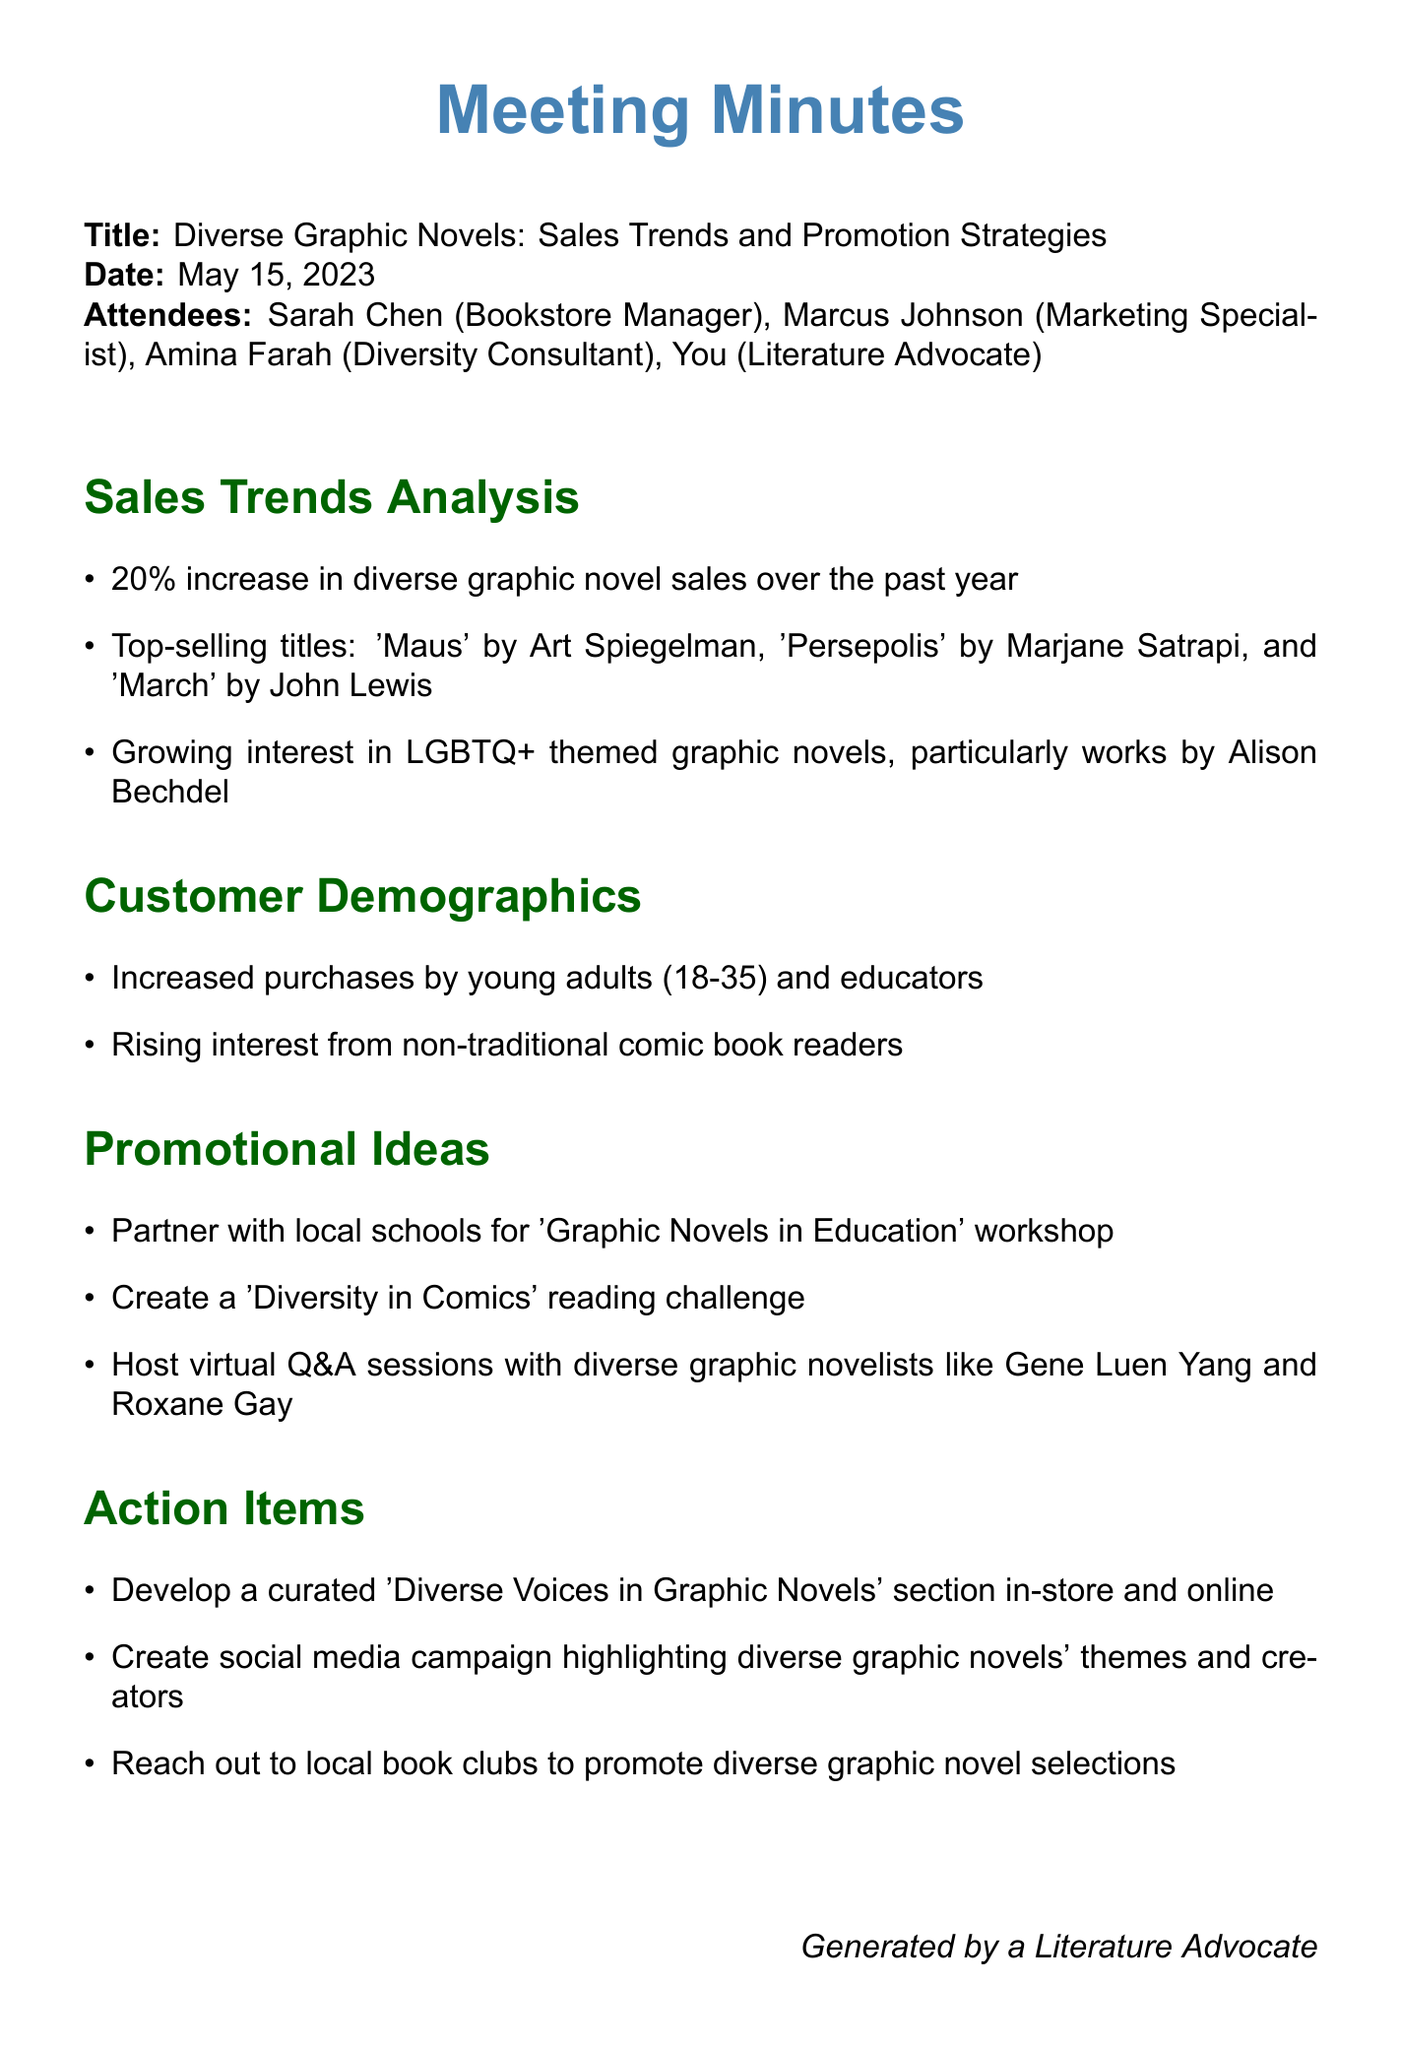What is the date of the meeting? The date of the meeting is explicitly stated in the document.
Answer: May 15, 2023 Who are the top-selling graphic novelists mentioned? The document lists specific titles and their authors that are top-selling graphic novels.
Answer: Art Spiegelman, Marjane Satrapi, John Lewis What is the percentage increase in diverse graphic novel sales? The document provides a specific statistic regarding the sales trend.
Answer: 20% Which demographic showed increased purchases? The document mentions specific customer demographics showing a rise in purchases.
Answer: Young adults (18-35) and educators What is one promotional idea mentioned in the meeting? The document lists several promotional strategies discussed during the meeting.
Answer: Graphic Novels in Education workshop What is the purpose of the 'Diversity in Comics' challenge? The document includes an agenda item that explains a new initiative for engagement.
Answer: To encourage diverse reading What action item involves social media? The document details specific actions to be taken based on the meeting's discussions.
Answer: Create social media campaign How many attendees were present at the meeting? The document lists the attendees at the meeting.
Answer: Four 